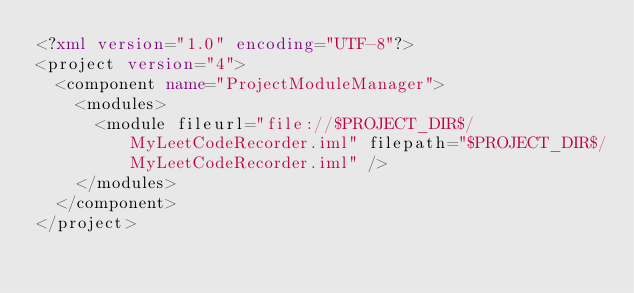Convert code to text. <code><loc_0><loc_0><loc_500><loc_500><_XML_><?xml version="1.0" encoding="UTF-8"?>
<project version="4">
  <component name="ProjectModuleManager">
    <modules>
      <module fileurl="file://$PROJECT_DIR$/MyLeetCodeRecorder.iml" filepath="$PROJECT_DIR$/MyLeetCodeRecorder.iml" />
    </modules>
  </component>
</project></code> 